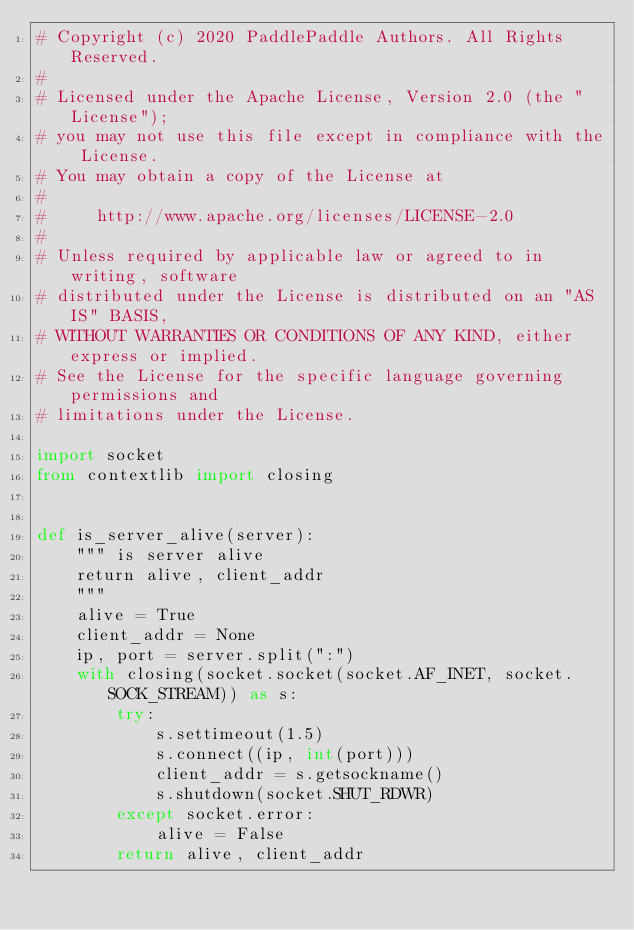<code> <loc_0><loc_0><loc_500><loc_500><_Python_># Copyright (c) 2020 PaddlePaddle Authors. All Rights Reserved.
#
# Licensed under the Apache License, Version 2.0 (the "License");
# you may not use this file except in compliance with the License.
# You may obtain a copy of the License at
#
#     http://www.apache.org/licenses/LICENSE-2.0
#
# Unless required by applicable law or agreed to in writing, software
# distributed under the License is distributed on an "AS IS" BASIS,
# WITHOUT WARRANTIES OR CONDITIONS OF ANY KIND, either express or implied.
# See the License for the specific language governing permissions and
# limitations under the License.

import socket
from contextlib import closing


def is_server_alive(server):
    """ is server alive
    return alive, client_addr
    """
    alive = True
    client_addr = None
    ip, port = server.split(":")
    with closing(socket.socket(socket.AF_INET, socket.SOCK_STREAM)) as s:
        try:
            s.settimeout(1.5)
            s.connect((ip, int(port)))
            client_addr = s.getsockname()
            s.shutdown(socket.SHUT_RDWR)
        except socket.error:
            alive = False
        return alive, client_addr
</code> 